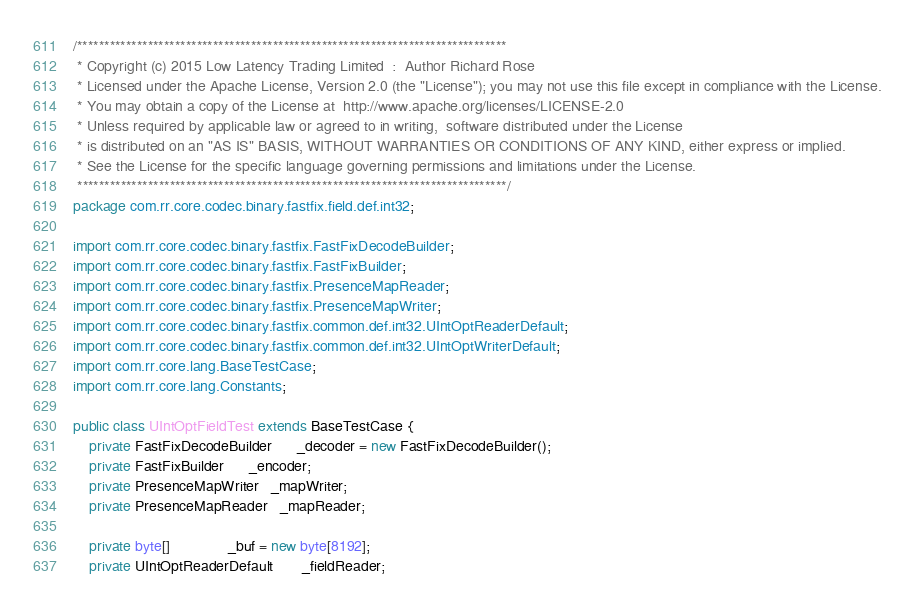Convert code to text. <code><loc_0><loc_0><loc_500><loc_500><_Java_>/*******************************************************************************
 * Copyright (c) 2015 Low Latency Trading Limited  :  Author Richard Rose
 * Licensed under the Apache License, Version 2.0 (the "License"); you may not use this file except in compliance with the License.
 * You may obtain a copy of the License at	http://www.apache.org/licenses/LICENSE-2.0
 * Unless required by applicable law or agreed to in writing,  software distributed under the License 
 * is distributed on an "AS IS" BASIS, WITHOUT WARRANTIES OR CONDITIONS OF ANY KIND, either express or implied.
 * See the License for the specific language governing permissions and limitations under the License.
 *******************************************************************************/
package com.rr.core.codec.binary.fastfix.field.def.int32;

import com.rr.core.codec.binary.fastfix.FastFixDecodeBuilder;
import com.rr.core.codec.binary.fastfix.FastFixBuilder;
import com.rr.core.codec.binary.fastfix.PresenceMapReader;
import com.rr.core.codec.binary.fastfix.PresenceMapWriter;
import com.rr.core.codec.binary.fastfix.common.def.int32.UIntOptReaderDefault;
import com.rr.core.codec.binary.fastfix.common.def.int32.UIntOptWriterDefault;
import com.rr.core.lang.BaseTestCase;
import com.rr.core.lang.Constants;

public class UIntOptFieldTest extends BaseTestCase {
    private FastFixDecodeBuilder      _decoder = new FastFixDecodeBuilder();
    private FastFixBuilder      _encoder;
    private PresenceMapWriter   _mapWriter;
    private PresenceMapReader   _mapReader;
    
    private byte[]              _buf = new byte[8192];
    private UIntOptReaderDefault       _fieldReader;</code> 